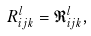<formula> <loc_0><loc_0><loc_500><loc_500>R _ { i j k } ^ { l } = \mathfrak { R } _ { i j k } ^ { l } ,</formula> 